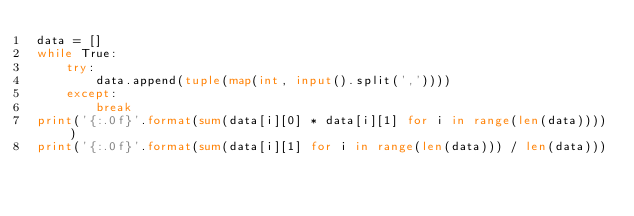<code> <loc_0><loc_0><loc_500><loc_500><_Python_>data = []
while True:
    try:
        data.append(tuple(map(int, input().split(','))))
    except:
        break
print('{:.0f}'.format(sum(data[i][0] * data[i][1] for i in range(len(data)))))
print('{:.0f}'.format(sum(data[i][1] for i in range(len(data))) / len(data)))</code> 